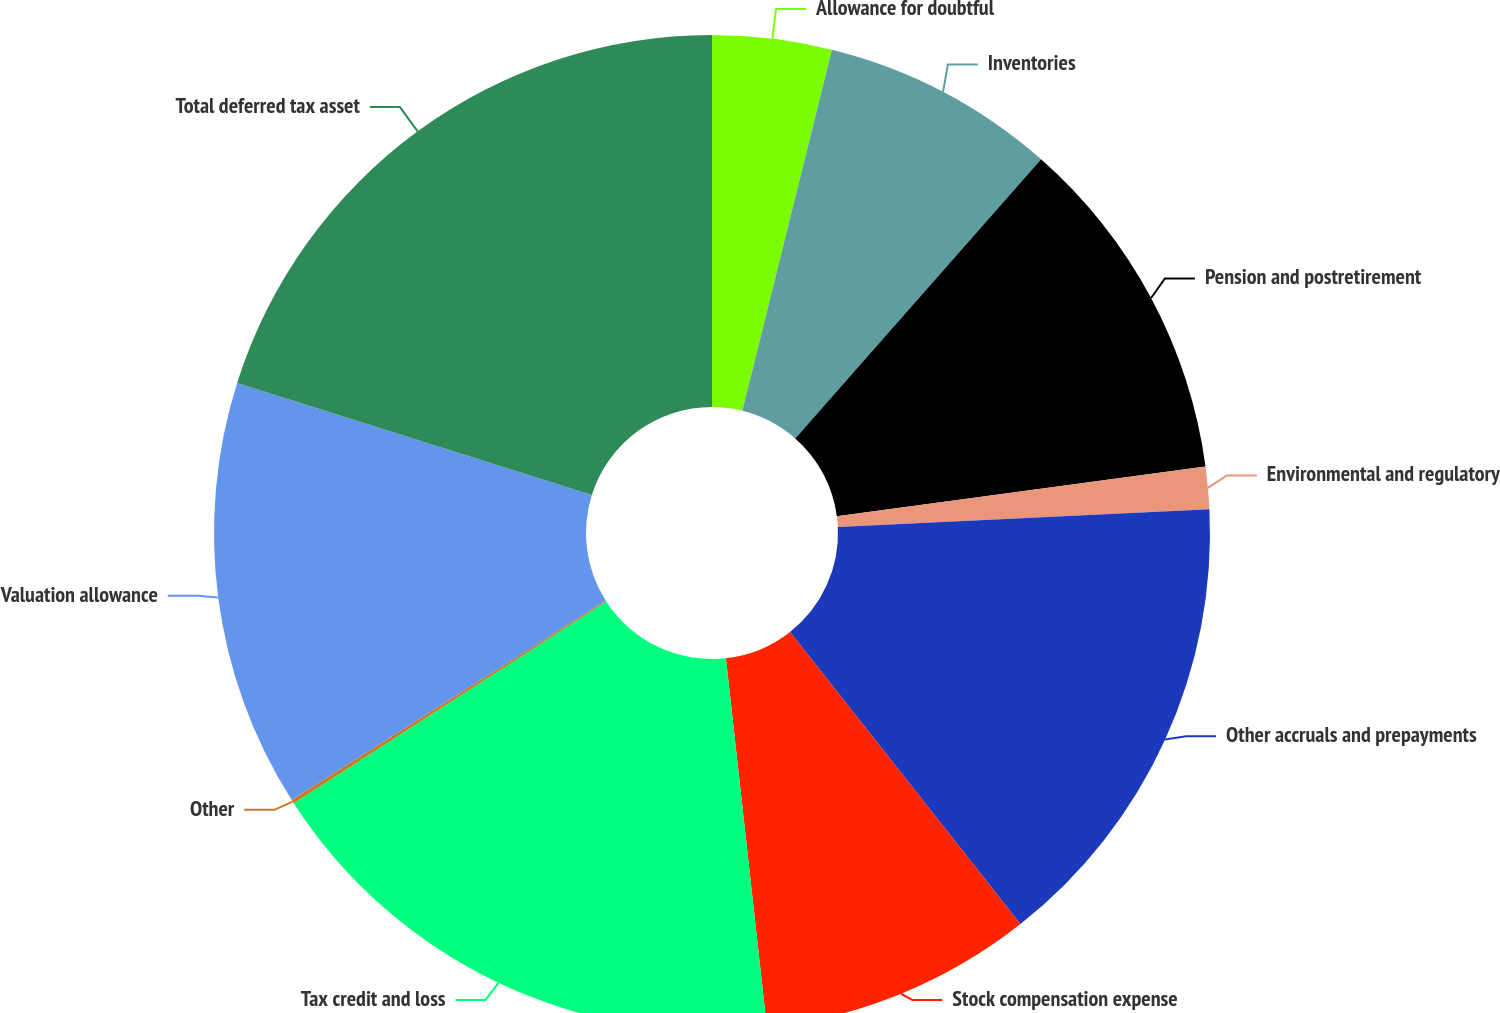Convert chart. <chart><loc_0><loc_0><loc_500><loc_500><pie_chart><fcel>Allowance for doubtful<fcel>Inventories<fcel>Pension and postretirement<fcel>Environmental and regulatory<fcel>Other accruals and prepayments<fcel>Stock compensation expense<fcel>Tax credit and loss<fcel>Other<fcel>Valuation allowance<fcel>Total deferred tax asset<nl><fcel>3.87%<fcel>7.62%<fcel>11.38%<fcel>1.37%<fcel>15.13%<fcel>8.87%<fcel>17.63%<fcel>0.12%<fcel>13.88%<fcel>20.13%<nl></chart> 